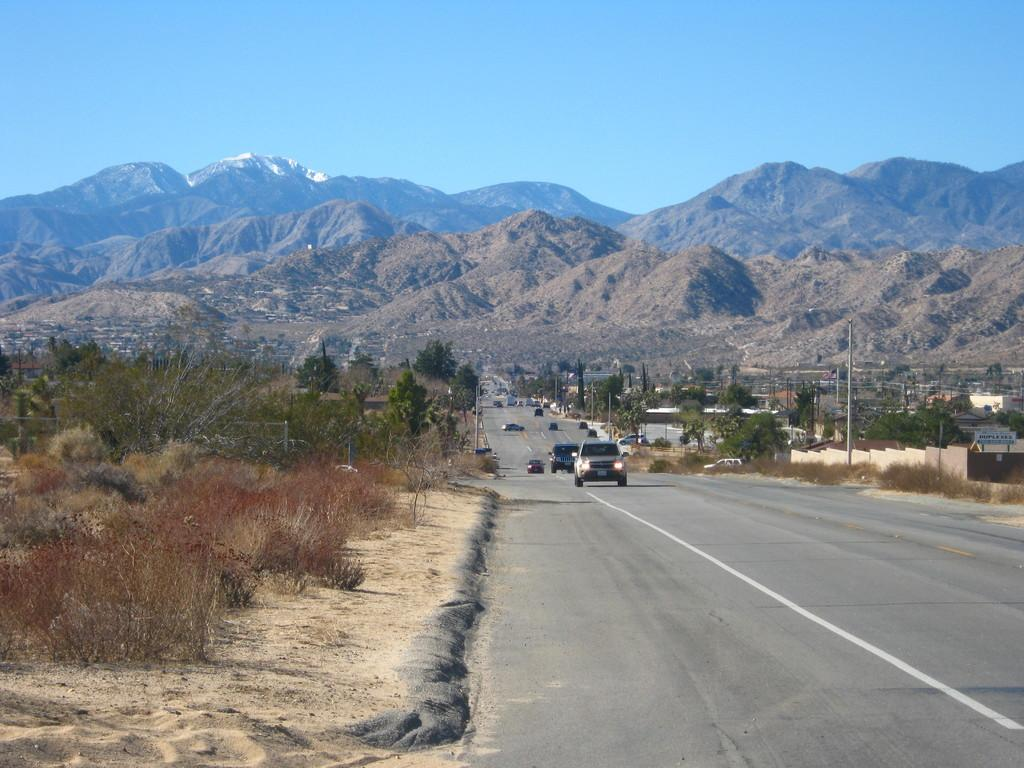What type of vehicles can be seen on the road in the image? There are motor vehicles on the road in the image. What structures are present in the image? There are poles in the image. What type of vegetation can be seen in the image? There are trees, bushes, and hills in the image. What natural landforms are visible in the image? There are mountains in the image. What part of the natural environment is visible in the image? The sky is visible in the image. What type of wine is being served at the picnic in the image? There is no picnic or wine present in the image; it features motor vehicles on the road, poles, trees, bushes, hills, mountains, and the sky. How many eggs are visible in the image? There are no eggs present in the image. 